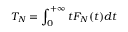Convert formula to latex. <formula><loc_0><loc_0><loc_500><loc_500>T _ { N } = \int _ { 0 } ^ { + \infty } t F _ { N } ( t ) d t</formula> 